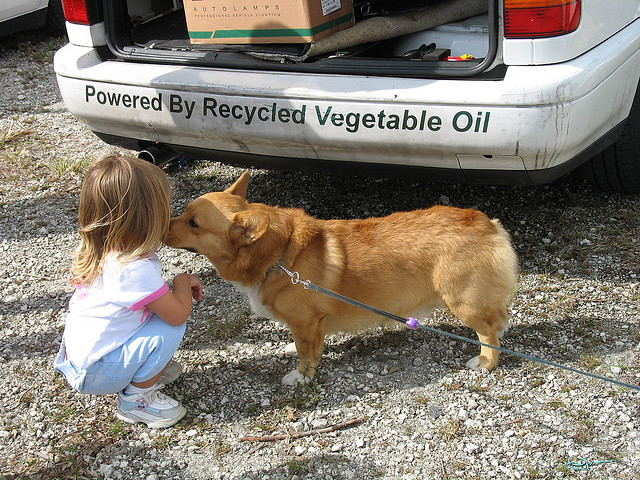Identify the text contained in this image. Powered By Recycled Vegetable Oil AUTOLAMPS 